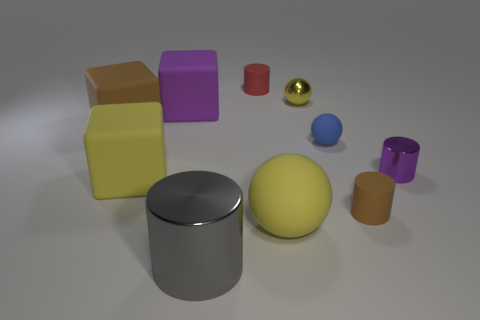Subtract all cubes. How many objects are left? 7 Add 5 matte cylinders. How many matte cylinders exist? 7 Subtract 0 green cylinders. How many objects are left? 10 Subtract all big blocks. Subtract all tiny brown rubber objects. How many objects are left? 6 Add 2 blue objects. How many blue objects are left? 3 